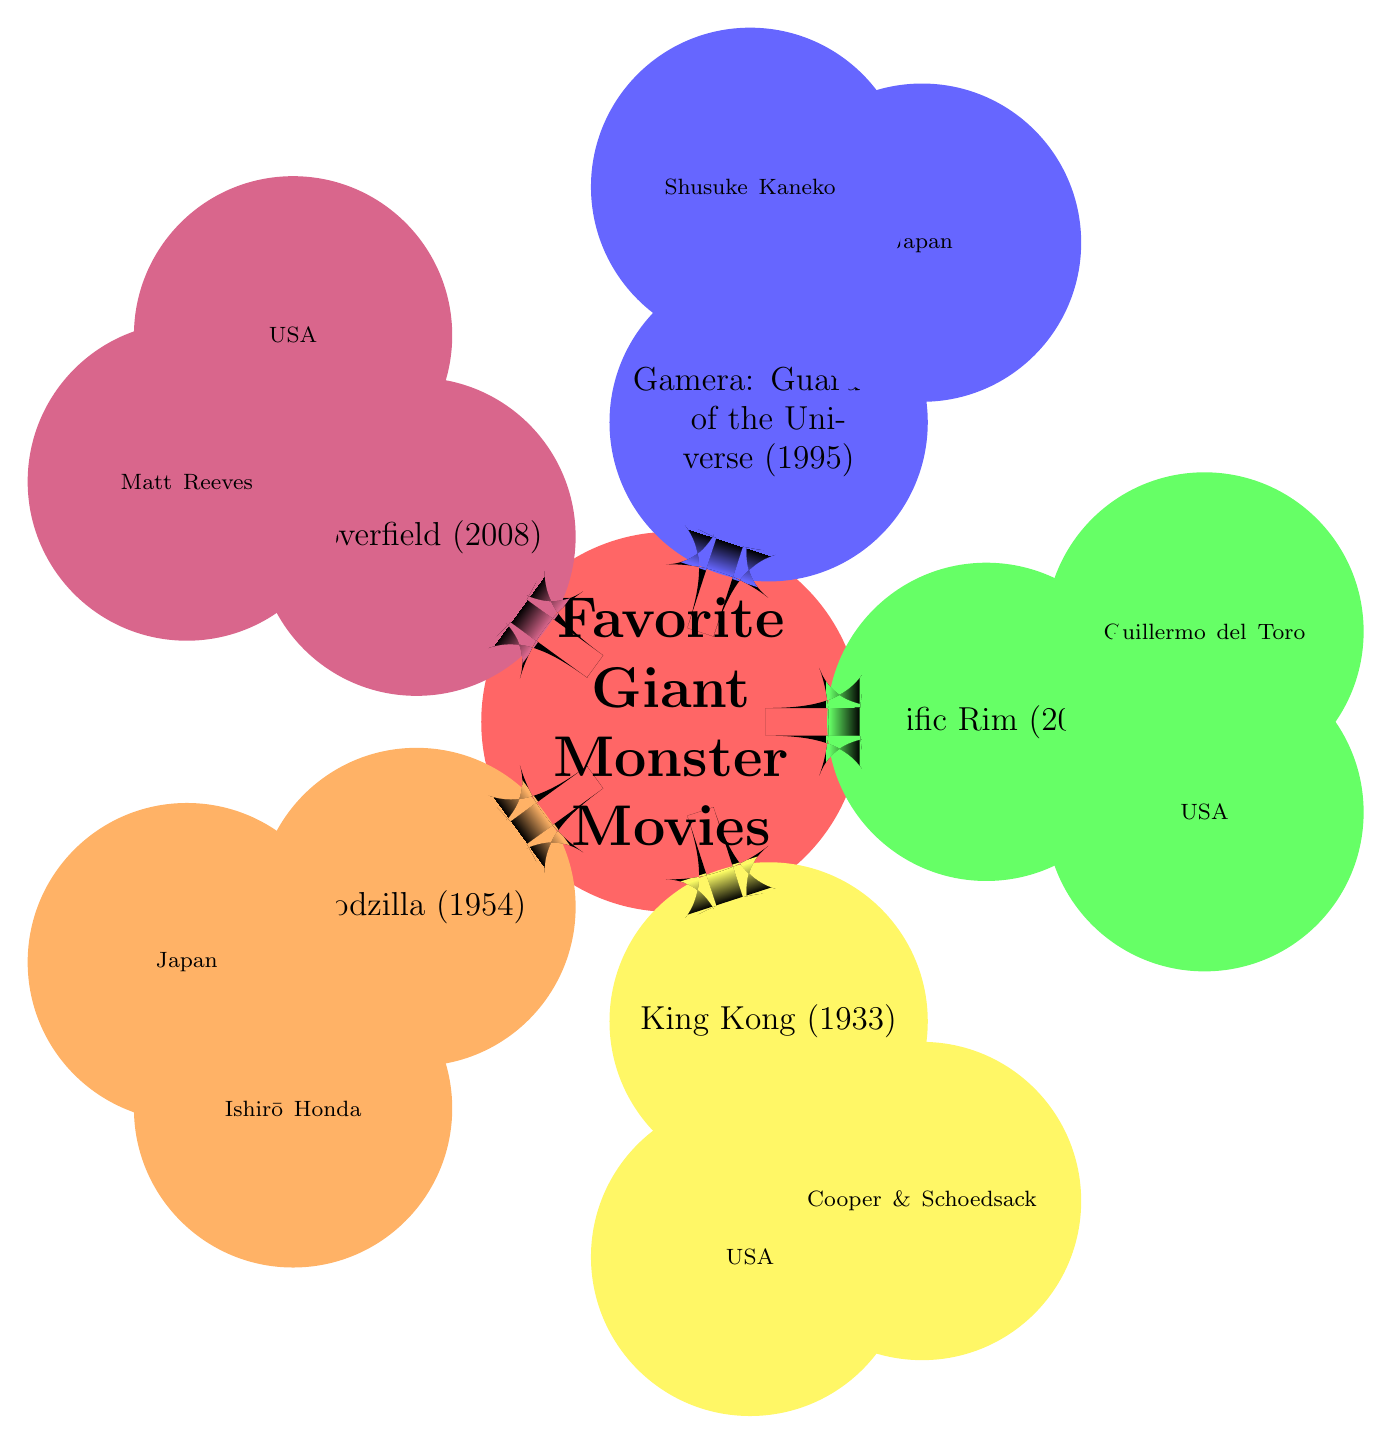What is the release date of Godzilla? The diagram shows the node for Godzilla (1954) which includes its details. The release date listed under this node is 1954.
Answer: 1954 Who directed King Kong? Looking at the King Kong (1933) node, two names are presented as directors: Merian C. Cooper and Ernest B. Schoedsack. The question asks for the director, which can be answered with either of these two names.
Answer: Cooper & Schoedsack What country produced Pacific Rim? The Pacific Rim (2013) node indicates that this movie was produced in the United States. By checking the node's details, we see 'United States' specified under the country.
Answer: United States Which movie features Gamera? The node labeled Gamera: Guardian of the Universe (1995) clearly indicates that Gamera is the central figure in this movie title. Thus, the answer is straightforward.
Answer: Gamera: Guardian of the Universe How many giant monster movies are listed in the mind map? By counting the nodes in the mind map, we find there are five key titles listed under Favorite Giant Monster Movies. This total counts each individual film node present.
Answer: 5 Which movie was directed by Guillermo del Toro? In the Pacific Rim (2013) node, the director is explicitly mentioned as Guillermo del Toro. Hence, the question directly corresponds to this information.
Answer: Pacific Rim What is the plot summary of Cloverfield? The Cloverfield (2008) node summarizes its plot as a group of New Yorkers trying to survive a massive monster attack, which is recorded through found footage. This is explicitly stated in the node's summary.
Answer: A group of New Yorkers tries to survive a massive monster attack on the city, documented through found footage What shared theme is evident in the movies listed? The mind map shows all mentioned films revolve around giant monsters causing chaos or destruction, which is reflected in their plot summaries. Therefore, the shared theme is about giant monster conflicts.
Answer: Giant monsters causing chaos or destruction 